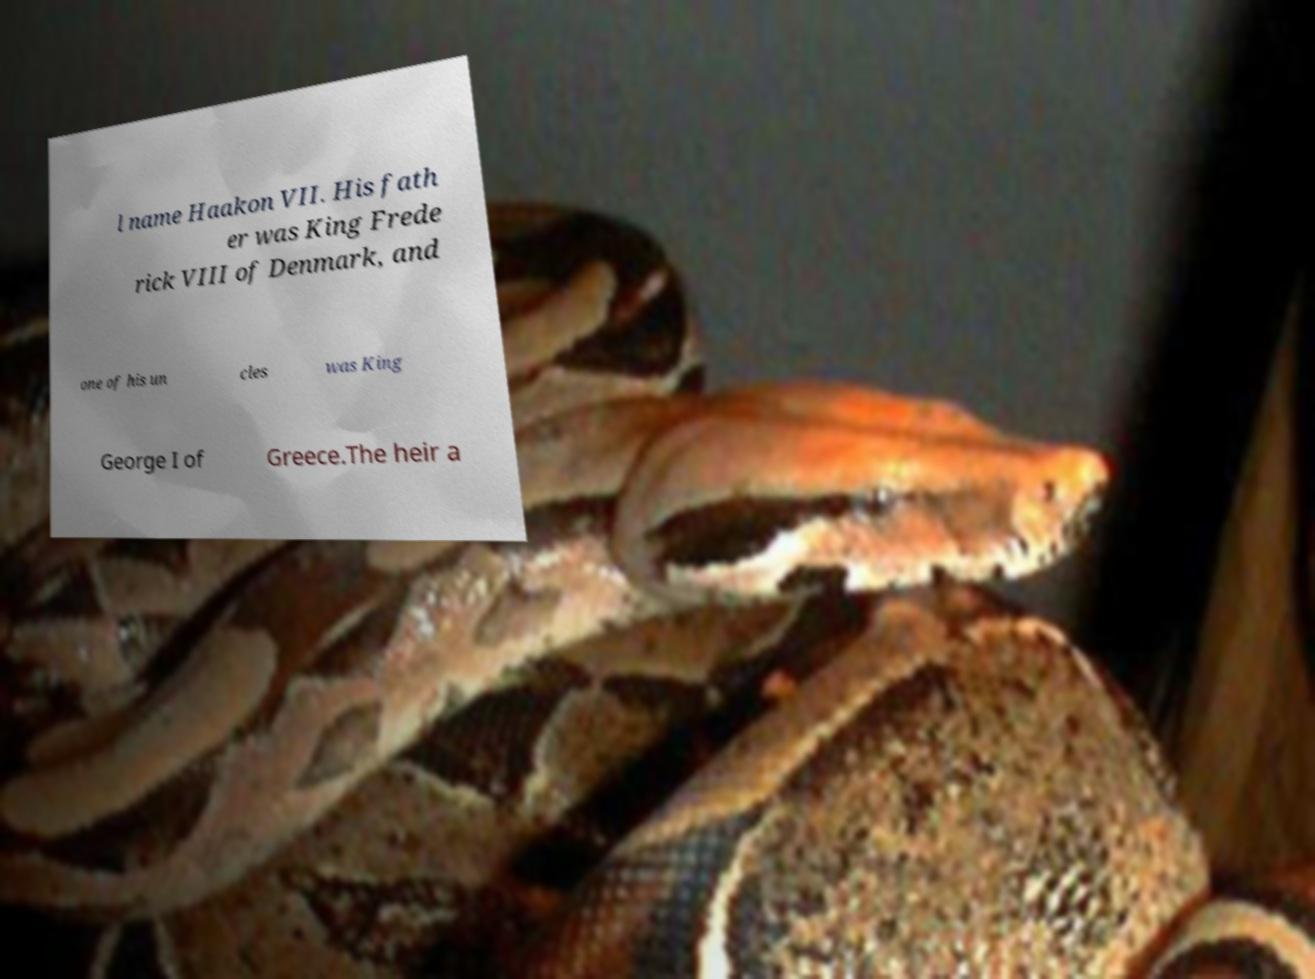Please read and relay the text visible in this image. What does it say? l name Haakon VII. His fath er was King Frede rick VIII of Denmark, and one of his un cles was King George I of Greece.The heir a 